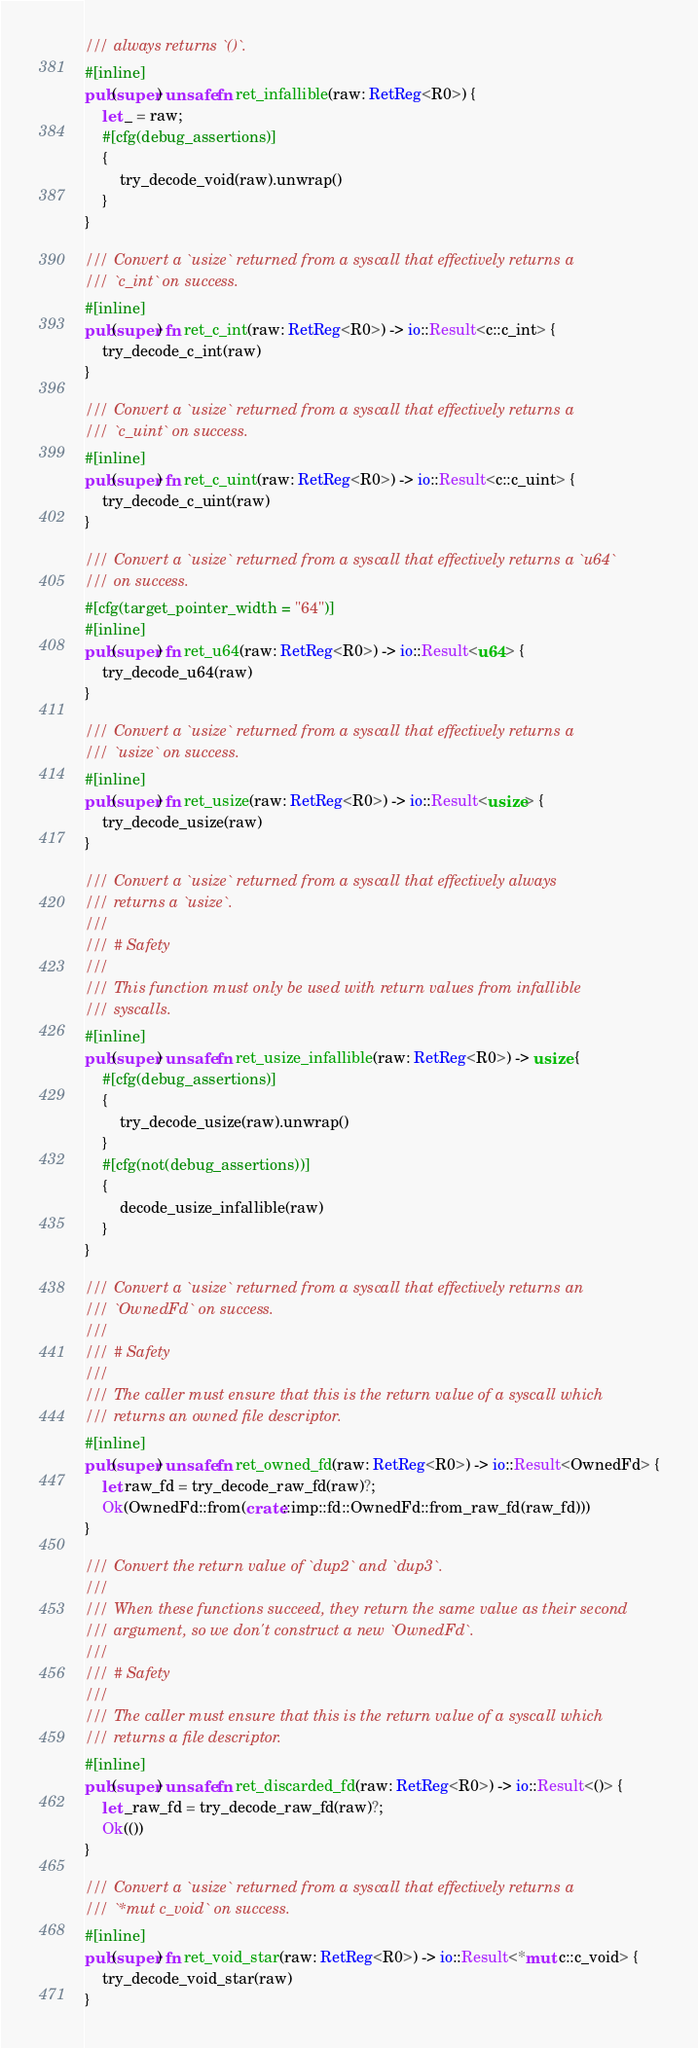Convert code to text. <code><loc_0><loc_0><loc_500><loc_500><_Rust_>/// always returns `()`.
#[inline]
pub(super) unsafe fn ret_infallible(raw: RetReg<R0>) {
    let _ = raw;
    #[cfg(debug_assertions)]
    {
        try_decode_void(raw).unwrap()
    }
}

/// Convert a `usize` returned from a syscall that effectively returns a
/// `c_int` on success.
#[inline]
pub(super) fn ret_c_int(raw: RetReg<R0>) -> io::Result<c::c_int> {
    try_decode_c_int(raw)
}

/// Convert a `usize` returned from a syscall that effectively returns a
/// `c_uint` on success.
#[inline]
pub(super) fn ret_c_uint(raw: RetReg<R0>) -> io::Result<c::c_uint> {
    try_decode_c_uint(raw)
}

/// Convert a `usize` returned from a syscall that effectively returns a `u64`
/// on success.
#[cfg(target_pointer_width = "64")]
#[inline]
pub(super) fn ret_u64(raw: RetReg<R0>) -> io::Result<u64> {
    try_decode_u64(raw)
}

/// Convert a `usize` returned from a syscall that effectively returns a
/// `usize` on success.
#[inline]
pub(super) fn ret_usize(raw: RetReg<R0>) -> io::Result<usize> {
    try_decode_usize(raw)
}

/// Convert a `usize` returned from a syscall that effectively always
/// returns a `usize`.
///
/// # Safety
///
/// This function must only be used with return values from infallible
/// syscalls.
#[inline]
pub(super) unsafe fn ret_usize_infallible(raw: RetReg<R0>) -> usize {
    #[cfg(debug_assertions)]
    {
        try_decode_usize(raw).unwrap()
    }
    #[cfg(not(debug_assertions))]
    {
        decode_usize_infallible(raw)
    }
}

/// Convert a `usize` returned from a syscall that effectively returns an
/// `OwnedFd` on success.
///
/// # Safety
///
/// The caller must ensure that this is the return value of a syscall which
/// returns an owned file descriptor.
#[inline]
pub(super) unsafe fn ret_owned_fd(raw: RetReg<R0>) -> io::Result<OwnedFd> {
    let raw_fd = try_decode_raw_fd(raw)?;
    Ok(OwnedFd::from(crate::imp::fd::OwnedFd::from_raw_fd(raw_fd)))
}

/// Convert the return value of `dup2` and `dup3`.
///
/// When these functions succeed, they return the same value as their second
/// argument, so we don't construct a new `OwnedFd`.
///
/// # Safety
///
/// The caller must ensure that this is the return value of a syscall which
/// returns a file descriptor.
#[inline]
pub(super) unsafe fn ret_discarded_fd(raw: RetReg<R0>) -> io::Result<()> {
    let _raw_fd = try_decode_raw_fd(raw)?;
    Ok(())
}

/// Convert a `usize` returned from a syscall that effectively returns a
/// `*mut c_void` on success.
#[inline]
pub(super) fn ret_void_star(raw: RetReg<R0>) -> io::Result<*mut c::c_void> {
    try_decode_void_star(raw)
}
</code> 